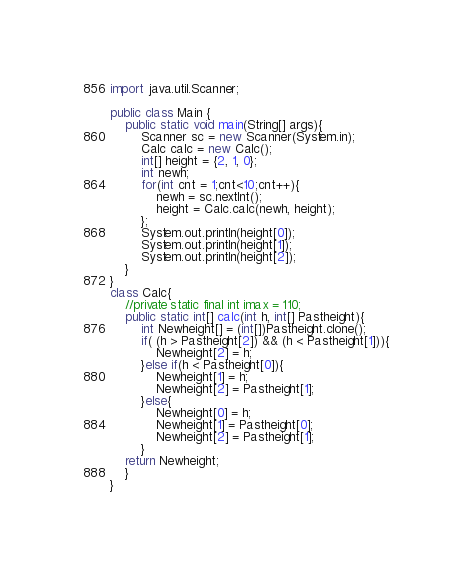Convert code to text. <code><loc_0><loc_0><loc_500><loc_500><_Java_>import java.util.Scanner;

public class Main {
	public static void main(String[] args){
		Scanner sc = new Scanner(System.in);
		Calc calc = new Calc();
		int[] height = {2, 1, 0};
		int newh;
		for(int cnt = 1;cnt<10;cnt++){
			newh = sc.nextInt();
			height = Calc.calc(newh, height);
		};
		System.out.println(height[0]);
		System.out.println(height[1]);
		System.out.println(height[2]);
	}
}
class Calc{
	//private static final int imax = 110;
	public static int[] calc(int h, int[] Pastheight){
		int Newheight[] = (int[])Pastheight.clone();
		if( (h > Pastheight[2]) && (h < Pastheight[1])){
			Newheight[2] = h;
		}else if(h < Pastheight[0]){
			Newheight[1] = h;
			Newheight[2] = Pastheight[1];
		}else{
			Newheight[0] = h;
			Newheight[1] = Pastheight[0];
			Newheight[2] = Pastheight[1];
		}
	return Newheight;
	}
}</code> 